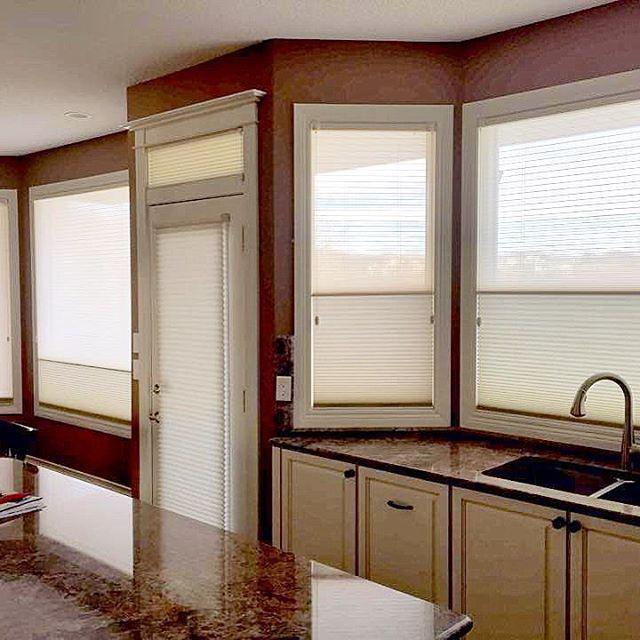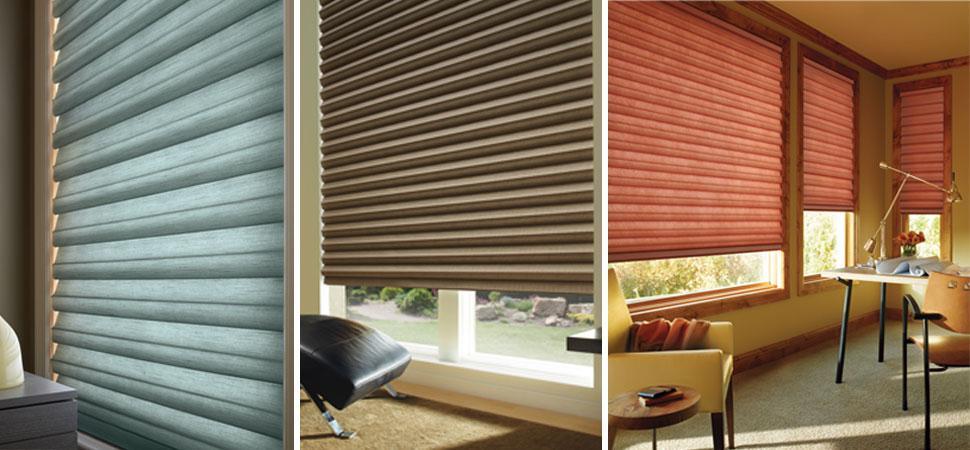The first image is the image on the left, the second image is the image on the right. Considering the images on both sides, is "Four sets of blinds are partially opened at the top of the window." valid? Answer yes or no. No. 